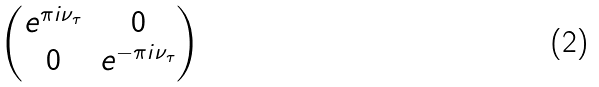<formula> <loc_0><loc_0><loc_500><loc_500>\begin{pmatrix} e ^ { \pi i \nu _ { \tau } } & 0 \\ 0 & e ^ { - \pi i \nu _ { \tau } } \end{pmatrix}</formula> 